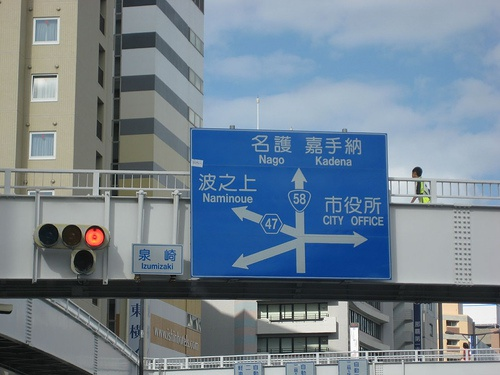Describe the objects in this image and their specific colors. I can see traffic light in darkgray, black, salmon, and maroon tones and backpack in darkgray, lightgreen, and khaki tones in this image. 